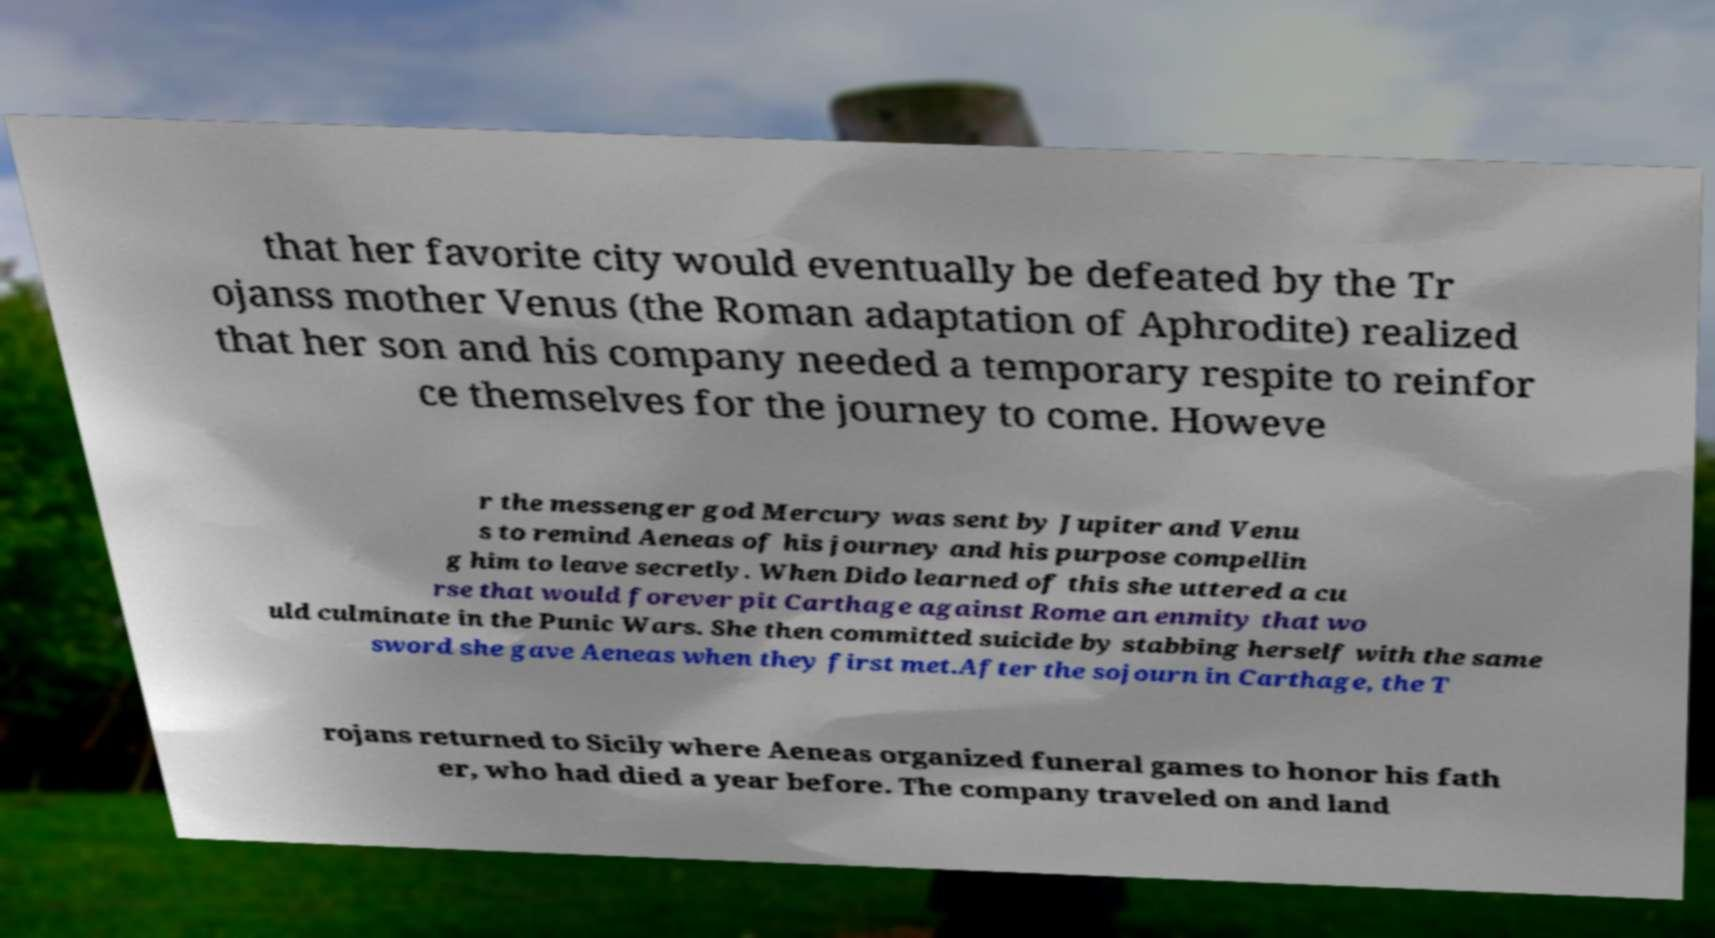Could you extract and type out the text from this image? that her favorite city would eventually be defeated by the Tr ojanss mother Venus (the Roman adaptation of Aphrodite) realized that her son and his company needed a temporary respite to reinfor ce themselves for the journey to come. Howeve r the messenger god Mercury was sent by Jupiter and Venu s to remind Aeneas of his journey and his purpose compellin g him to leave secretly. When Dido learned of this she uttered a cu rse that would forever pit Carthage against Rome an enmity that wo uld culminate in the Punic Wars. She then committed suicide by stabbing herself with the same sword she gave Aeneas when they first met.After the sojourn in Carthage, the T rojans returned to Sicily where Aeneas organized funeral games to honor his fath er, who had died a year before. The company traveled on and land 